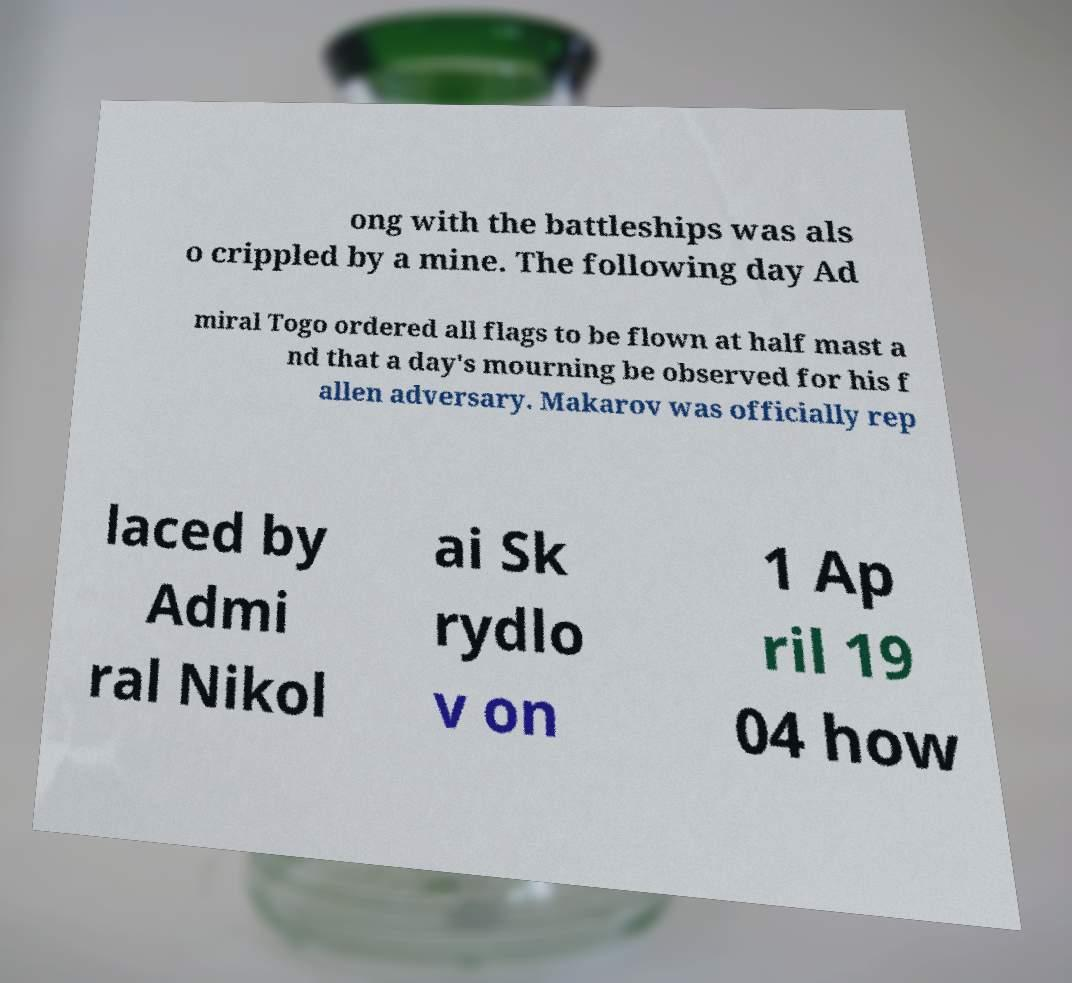There's text embedded in this image that I need extracted. Can you transcribe it verbatim? ong with the battleships was als o crippled by a mine. The following day Ad miral Togo ordered all flags to be flown at half mast a nd that a day's mourning be observed for his f allen adversary. Makarov was officially rep laced by Admi ral Nikol ai Sk rydlo v on 1 Ap ril 19 04 how 